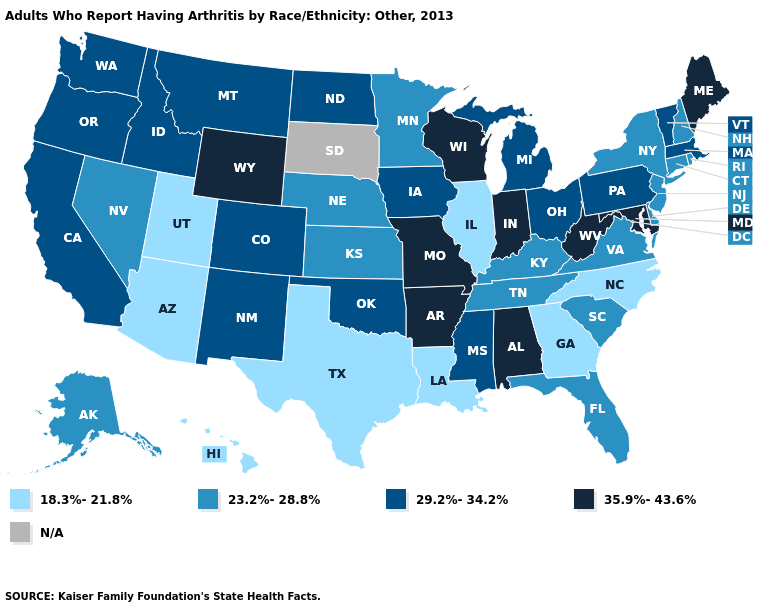Does the map have missing data?
Write a very short answer. Yes. Is the legend a continuous bar?
Quick response, please. No. Does the first symbol in the legend represent the smallest category?
Keep it brief. Yes. What is the lowest value in the Northeast?
Give a very brief answer. 23.2%-28.8%. What is the lowest value in states that border Utah?
Keep it brief. 18.3%-21.8%. Among the states that border Wisconsin , does Minnesota have the highest value?
Concise answer only. No. What is the value of Delaware?
Keep it brief. 23.2%-28.8%. What is the value of California?
Concise answer only. 29.2%-34.2%. What is the value of Indiana?
Concise answer only. 35.9%-43.6%. What is the highest value in the USA?
Give a very brief answer. 35.9%-43.6%. Name the states that have a value in the range N/A?
Write a very short answer. South Dakota. 